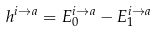<formula> <loc_0><loc_0><loc_500><loc_500>h ^ { i \to a } = E _ { 0 } ^ { i \to a } - E _ { 1 } ^ { i \to a }</formula> 